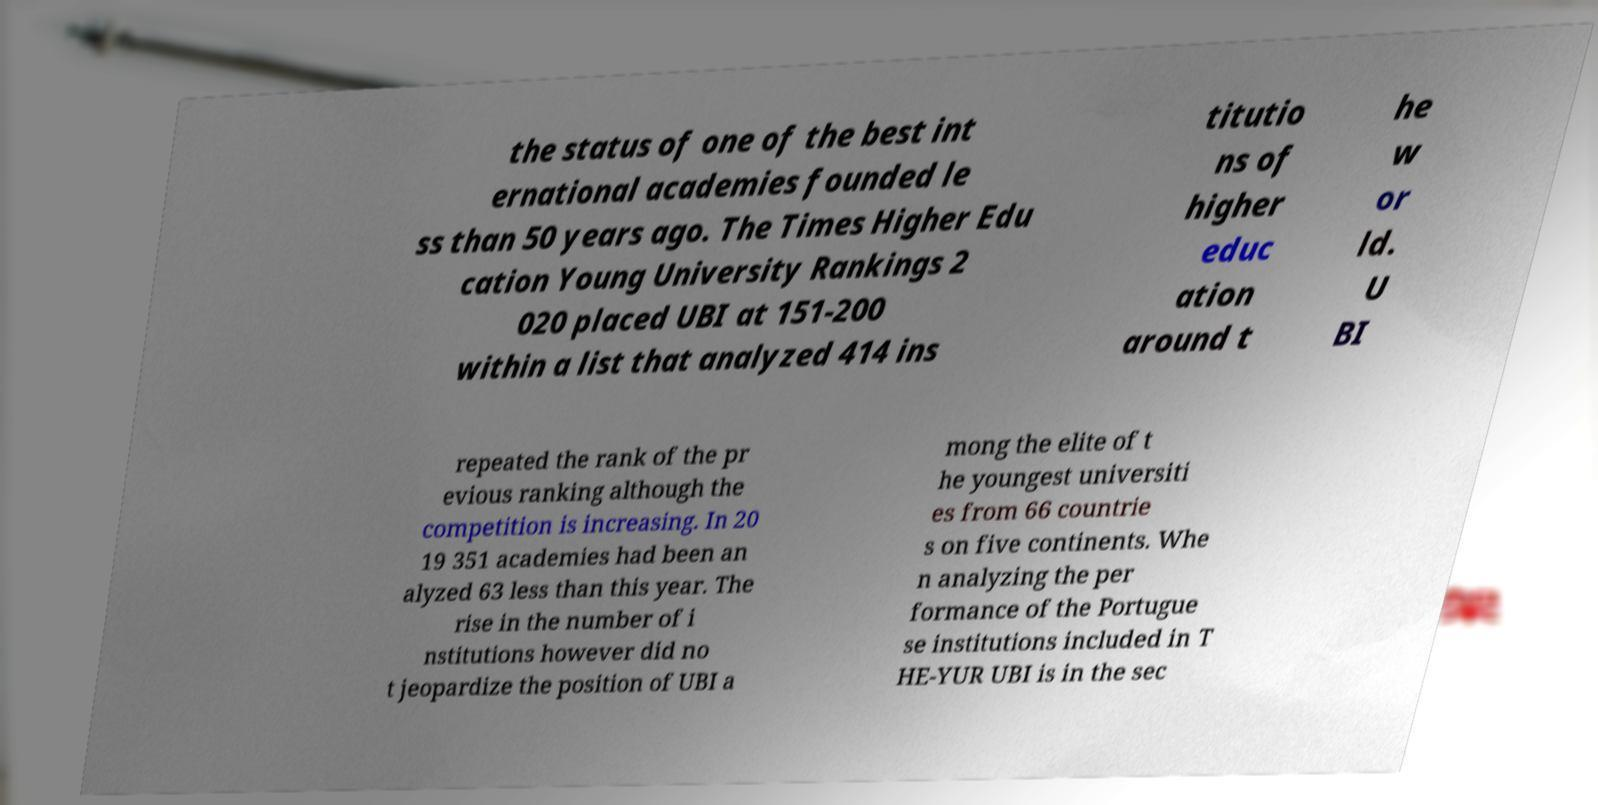I need the written content from this picture converted into text. Can you do that? the status of one of the best int ernational academies founded le ss than 50 years ago. The Times Higher Edu cation Young University Rankings 2 020 placed UBI at 151-200 within a list that analyzed 414 ins titutio ns of higher educ ation around t he w or ld. U BI repeated the rank of the pr evious ranking although the competition is increasing. In 20 19 351 academies had been an alyzed 63 less than this year. The rise in the number of i nstitutions however did no t jeopardize the position of UBI a mong the elite of t he youngest universiti es from 66 countrie s on five continents. Whe n analyzing the per formance of the Portugue se institutions included in T HE-YUR UBI is in the sec 